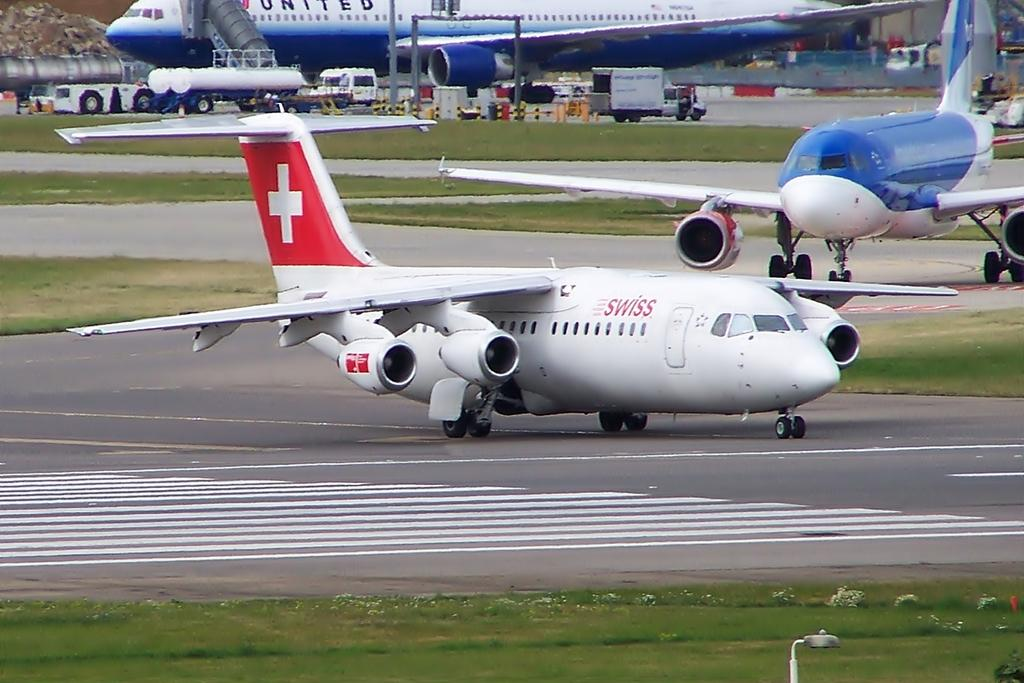<image>
Write a terse but informative summary of the picture. a swiss air plane is sitting at an airport 